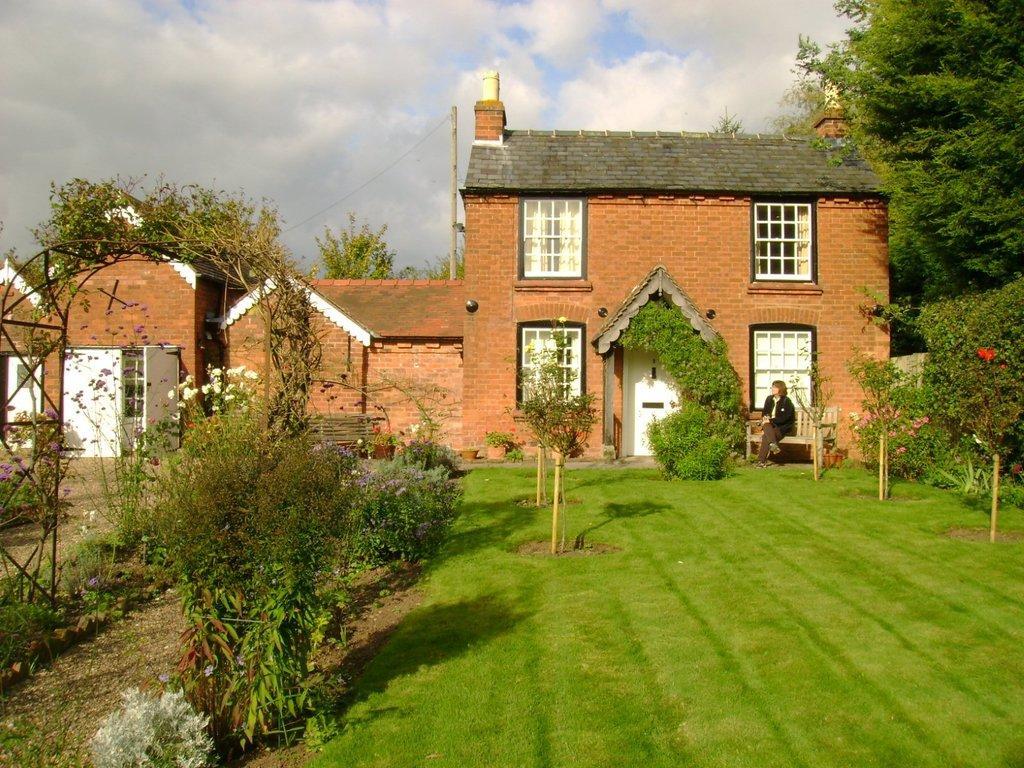How would you summarize this image in a sentence or two? In this image there is a big building, in front of that there is a bench where a lady is sitting, also there is grass, plants, trees and clouds in the sky. 